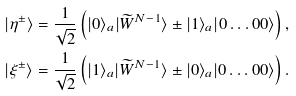<formula> <loc_0><loc_0><loc_500><loc_500>& | \eta ^ { \pm } \rangle = \frac { 1 } { \sqrt { 2 } } \left ( | 0 \rangle _ { a } | \widetilde { W } ^ { N - 1 } \rangle \pm | 1 \rangle _ { a } | 0 \dots 0 0 \rangle \right ) , \\ & | \xi ^ { \pm } \rangle = \frac { 1 } { \sqrt { 2 } } \left ( | 1 \rangle _ { a } | \widetilde { W } ^ { N - 1 } \rangle \pm | 0 \rangle _ { a } | 0 \dots 0 0 \rangle \right ) .</formula> 